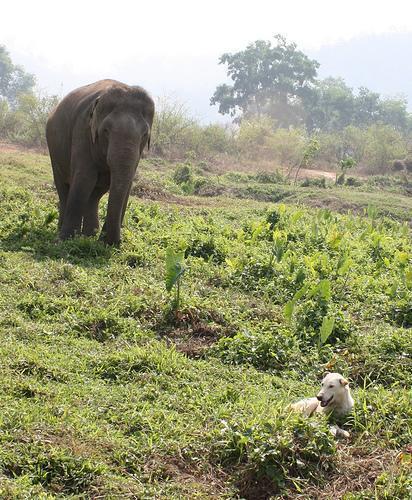How many animals are in the picture?
Give a very brief answer. 2. 